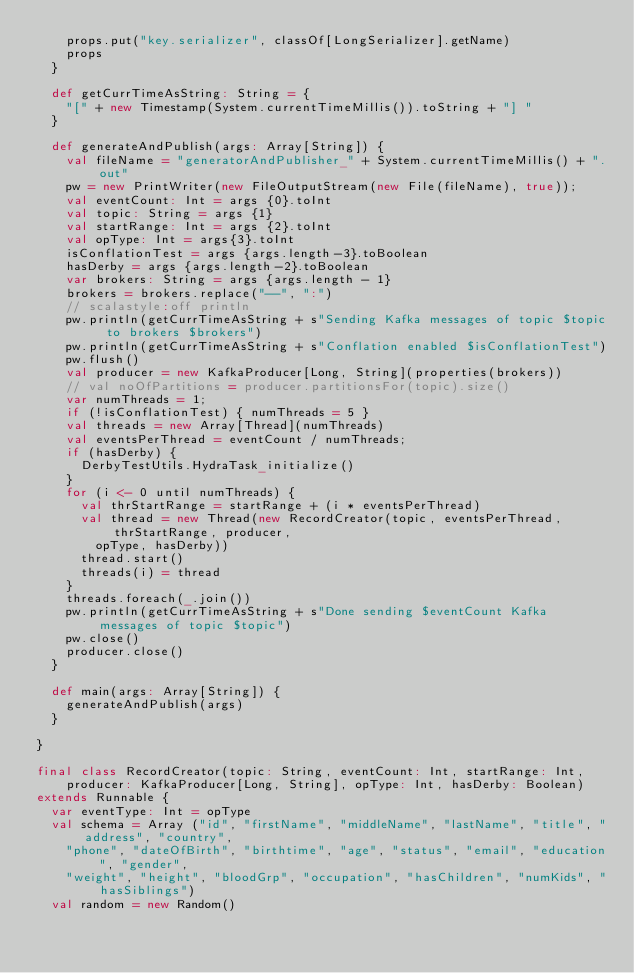Convert code to text. <code><loc_0><loc_0><loc_500><loc_500><_Scala_>    props.put("key.serializer", classOf[LongSerializer].getName)
    props
  }

  def getCurrTimeAsString: String = {
    "[" + new Timestamp(System.currentTimeMillis()).toString + "] "
  }

  def generateAndPublish(args: Array[String]) {
    val fileName = "generatorAndPublisher_" + System.currentTimeMillis() + ".out"
    pw = new PrintWriter(new FileOutputStream(new File(fileName), true));
    val eventCount: Int = args {0}.toInt
    val topic: String = args {1}
    val startRange: Int = args {2}.toInt
    val opType: Int = args{3}.toInt
    isConflationTest = args {args.length-3}.toBoolean
    hasDerby = args {args.length-2}.toBoolean
    var brokers: String = args {args.length - 1}
    brokers = brokers.replace("--", ":")
    // scalastyle:off println
    pw.println(getCurrTimeAsString + s"Sending Kafka messages of topic $topic to brokers $brokers")
    pw.println(getCurrTimeAsString + s"Conflation enabled $isConflationTest")
    pw.flush()
    val producer = new KafkaProducer[Long, String](properties(brokers))
    // val noOfPartitions = producer.partitionsFor(topic).size()
    var numThreads = 1;
    if (!isConflationTest) { numThreads = 5 }
    val threads = new Array[Thread](numThreads)
    val eventsPerThread = eventCount / numThreads;
    if (hasDerby) {
      DerbyTestUtils.HydraTask_initialize()
    }
    for (i <- 0 until numThreads) {
      val thrStartRange = startRange + (i * eventsPerThread)
      val thread = new Thread(new RecordCreator(topic, eventsPerThread, thrStartRange, producer,
        opType, hasDerby))
      thread.start()
      threads(i) = thread
    }
    threads.foreach(_.join())
    pw.println(getCurrTimeAsString + s"Done sending $eventCount Kafka messages of topic $topic")
    pw.close()
    producer.close()
  }

  def main(args: Array[String]) {
    generateAndPublish(args)
  }

}

final class RecordCreator(topic: String, eventCount: Int, startRange: Int,
    producer: KafkaProducer[Long, String], opType: Int, hasDerby: Boolean)
extends Runnable {
  var eventType: Int = opType
  val schema = Array ("id", "firstName", "middleName", "lastName", "title", "address", "country",
    "phone", "dateOfBirth", "birthtime", "age", "status", "email", "education", "gender",
    "weight", "height", "bloodGrp", "occupation", "hasChildren", "numKids", "hasSiblings")
  val random = new Random()</code> 